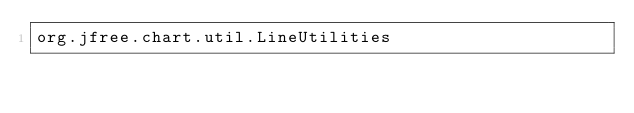<code> <loc_0><loc_0><loc_500><loc_500><_Rust_>org.jfree.chart.util.LineUtilities
</code> 